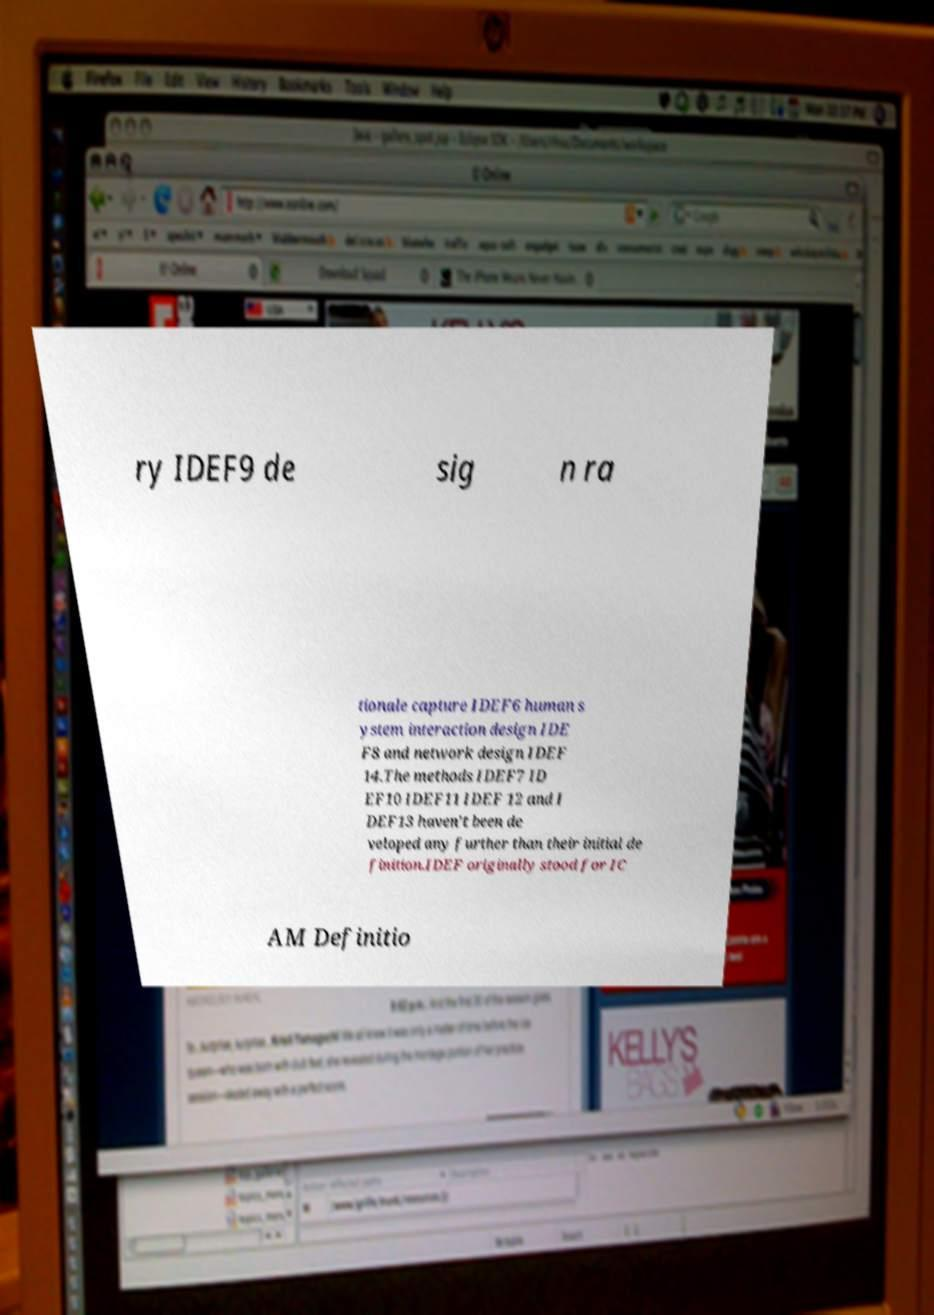What messages or text are displayed in this image? I need them in a readable, typed format. ry IDEF9 de sig n ra tionale capture IDEF6 human s ystem interaction design IDE F8 and network design IDEF 14.The methods IDEF7 ID EF10 IDEF11 IDEF 12 and I DEF13 haven't been de veloped any further than their initial de finition.IDEF originally stood for IC AM Definitio 